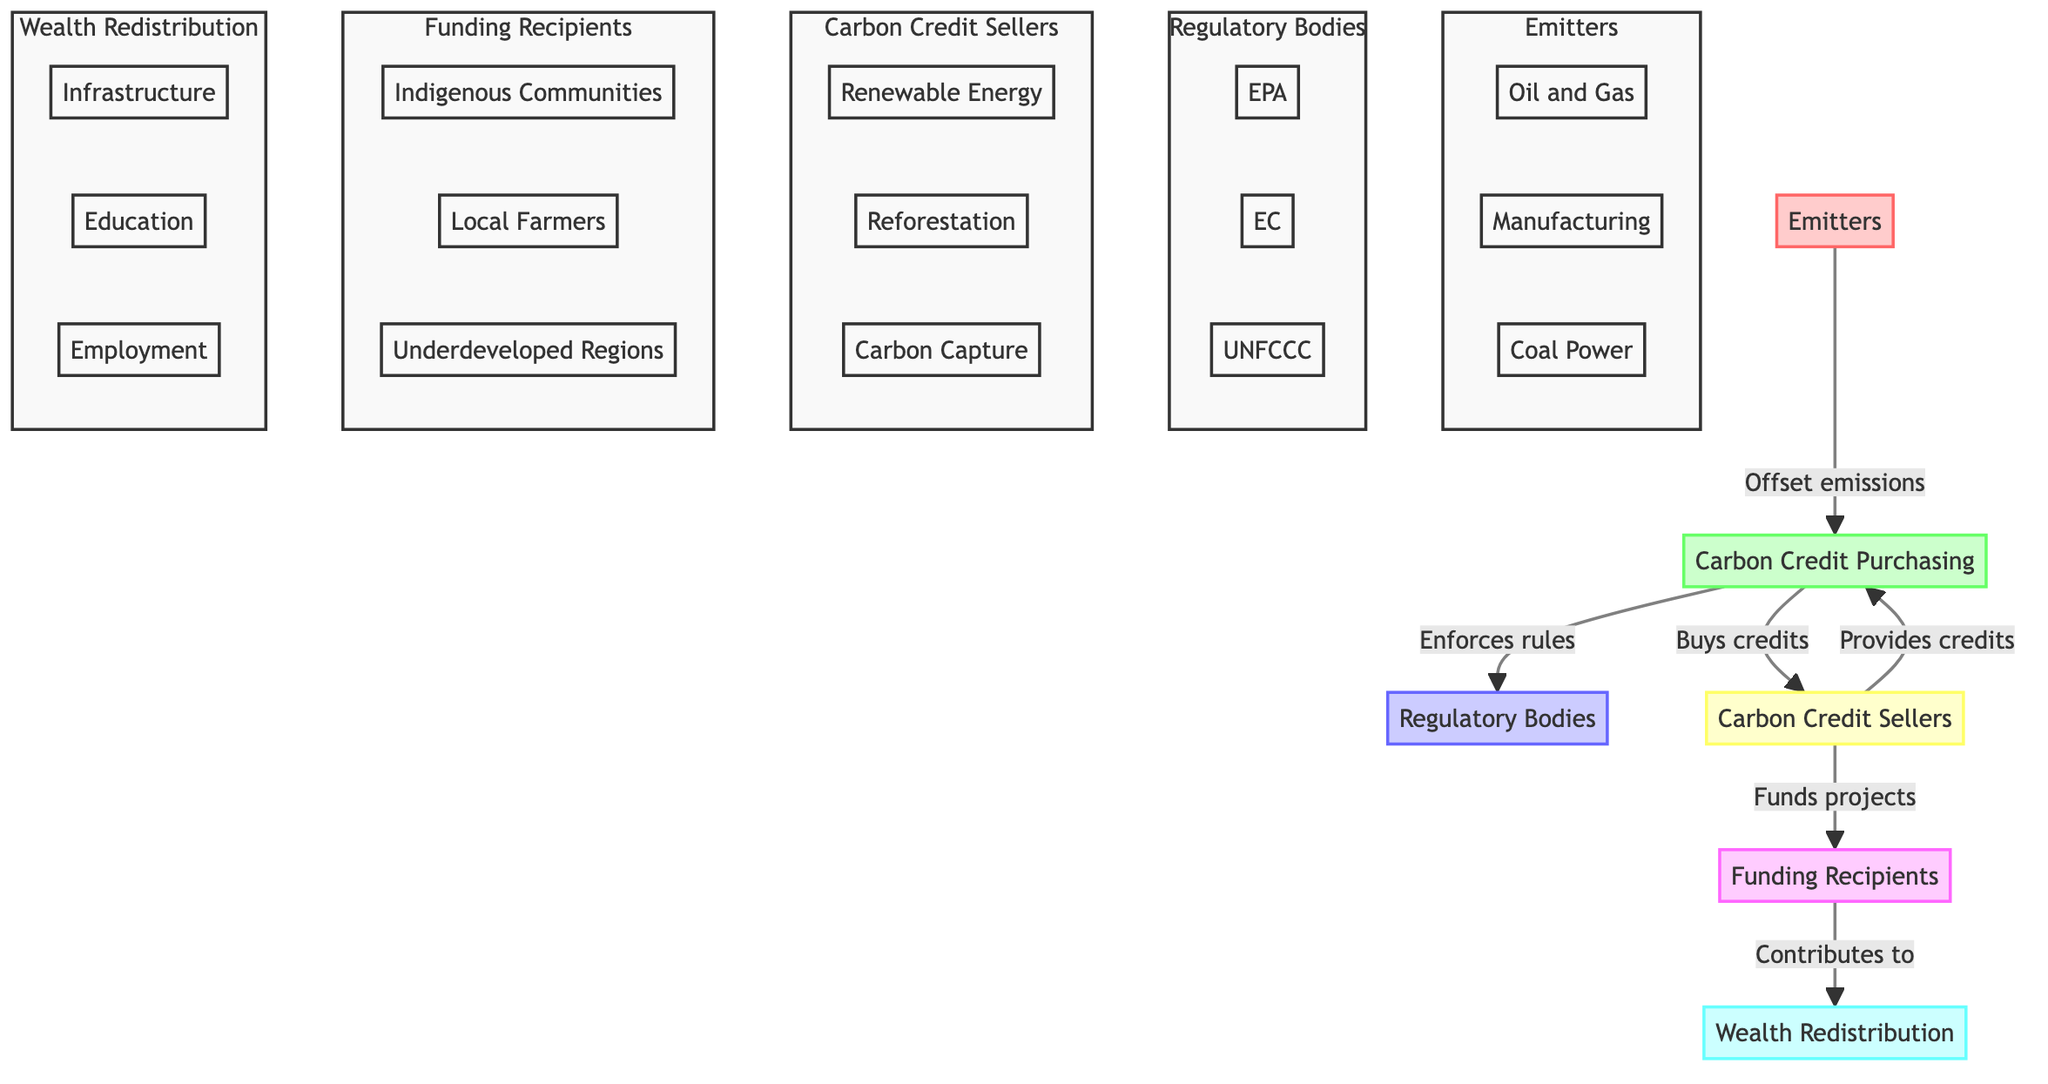What are the emitters in this diagram? The emitters are represented at the bottom of the diagram and include entities such as Oil and Gas Corporations, Manufacturing Plants, and Coal Power Stations.
Answer: Emitters: Oil and Gas, Manufacturing, Coal Power Which entity purchases carbon credits? Carbon Credit Purchasing is the entity responsible for buying carbon credits to offset emissions in the flow of funds.
Answer: Carbon Credit Purchasing How many types of carbon credit sellers are in the diagram? There are three types of carbon credit sellers shown in the diagram: Renewable Energy Projects, Reforestation Projects, and Carbon Capture Initiatives.
Answer: Three What is the primary purpose of regulatory bodies? Regulatory Bodies enforce emission caps and trading rules, ensuring compliance within the carbon credit market.
Answer: Enforce rules Which funding recipients are identified in the diagram? The funding recipients include Indigenous Communities, Local Farmers, and Underdeveloped Regions, all of which receive funding from carbon credit transactions.
Answer: Indigenous Communities, Local Farmers, Underdeveloped Regions How do carbon credit sellers contribute to wealth redistribution? Carbon Credit Sellers fund projects that support Funding Recipients, which help bridge the wealth gap through financial flows, ultimately contributing to Wealth Redistribution.
Answer: Fund projects What is the connection between carbon credit purchasing and regulatory bodies? Carbon Credit Purchasing is connected to Regulatory Bodies as these bodies enforce the rules under which carbon credits are bought and sold, ensuring compliance with regulations.
Answer: Enforces rules How does funding from carbon credit transactions affect local communities? The funding provided to communities through carbon credit transactions contributes to sustainable development initiatives, helping to support local economies and social structures.
Answer: Supports development In how many areas does wealth redistribution occur according to the diagram? The diagram highlights three areas of wealth redistribution: Infrastructure Development, Educational Programs, and Local Employment Opportunities.
Answer: Three areas 